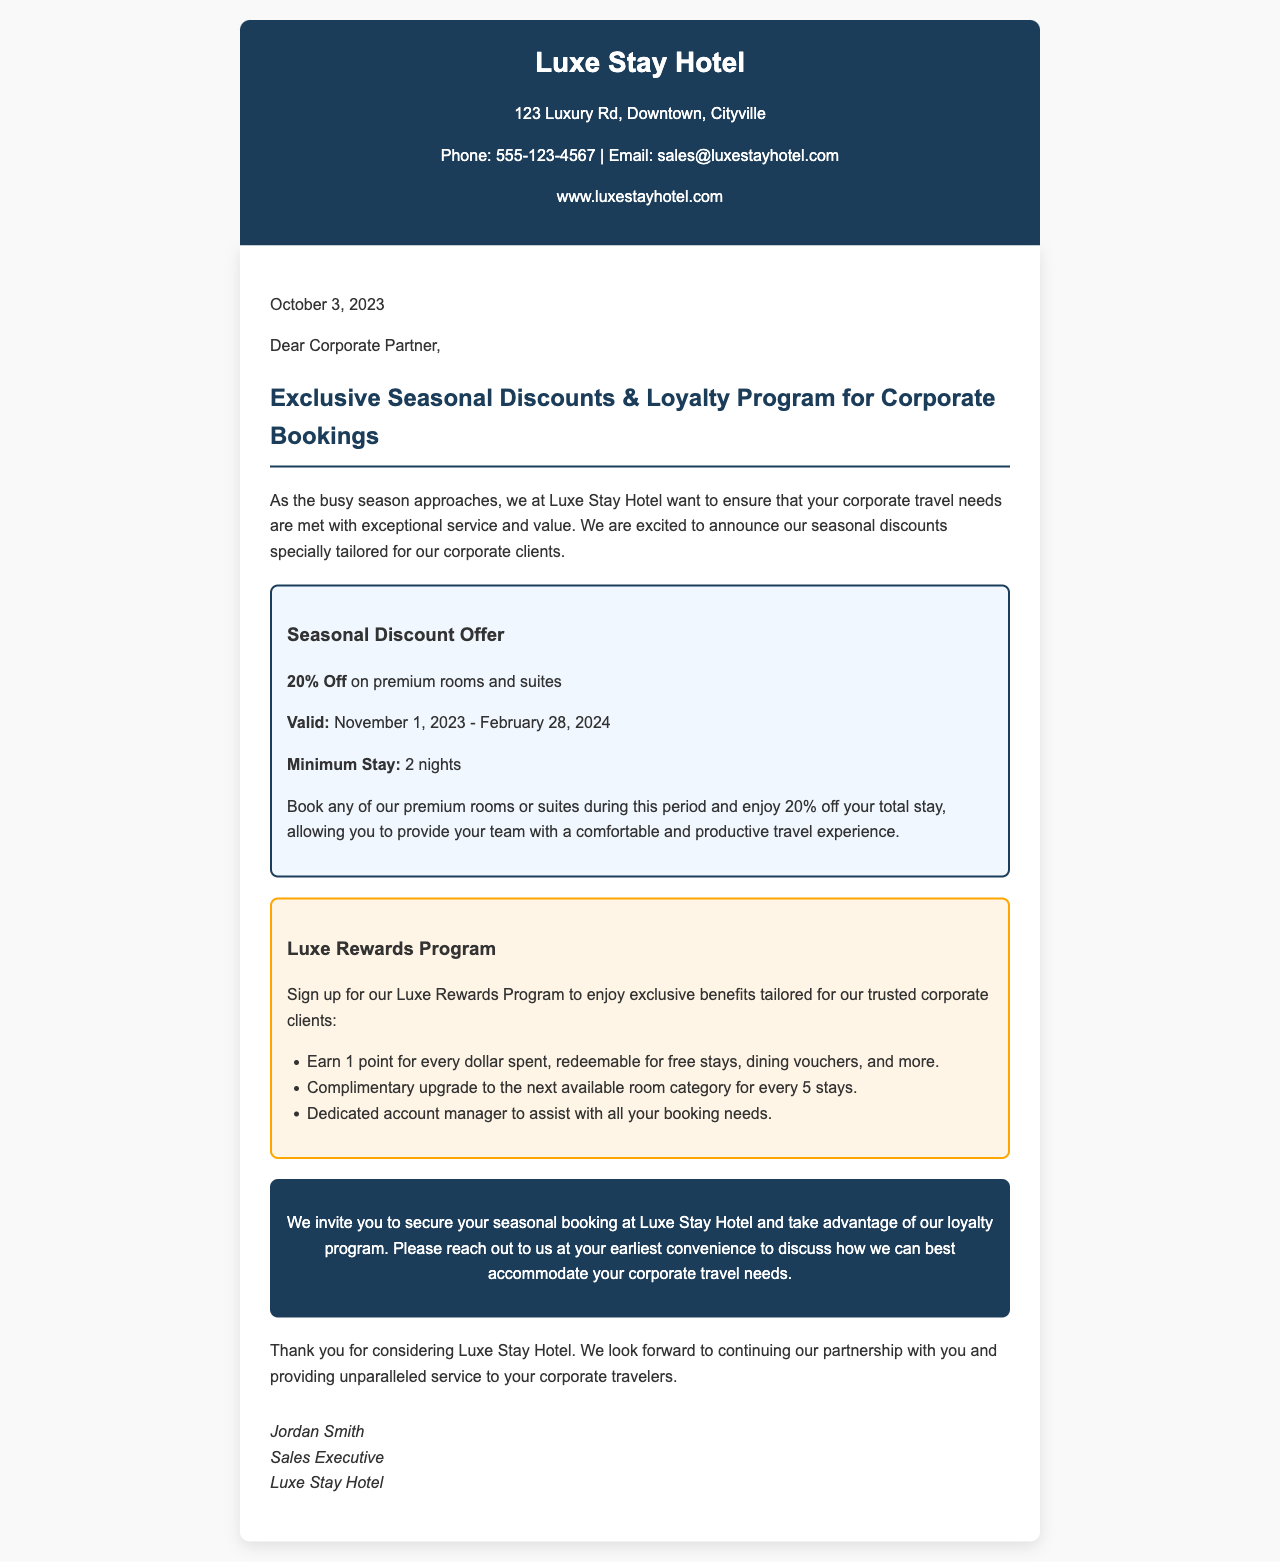What is the name of the hotel? The name of the hotel is mentioned in the header of the letter.
Answer: Luxe Stay Hotel What is the phone number provided? The document lists a contact phone number in the header section.
Answer: 555-123-4567 What discount is being offered on premium rooms? The specific discount on premium rooms is highlighted in the letter.
Answer: 20% Off What is the validity period for the seasonal discount? The document specifies the start and end dates for the discount.
Answer: November 1, 2023 - February 28, 2024 What is the minimum stay requirement to avail the discount? The letter mentions a minimum stay condition to qualify for the offer.
Answer: 2 nights How many points do corporate clients earn for every dollar spent in the loyalty program? The loyalty program section of the document outlines the points system.
Answer: 1 point What is given as a complimentary benefit after every 5 stays? The loyalty program lists a benefit linked to the number of stays.
Answer: Complimentary upgrade Who is the author of the letter? The signature at the end reveals who wrote the letter.
Answer: Jordan Smith What type of booking does the letter invite the reader to secure? The call to action specifies the kind of booking being encouraged.
Answer: Seasonal booking 